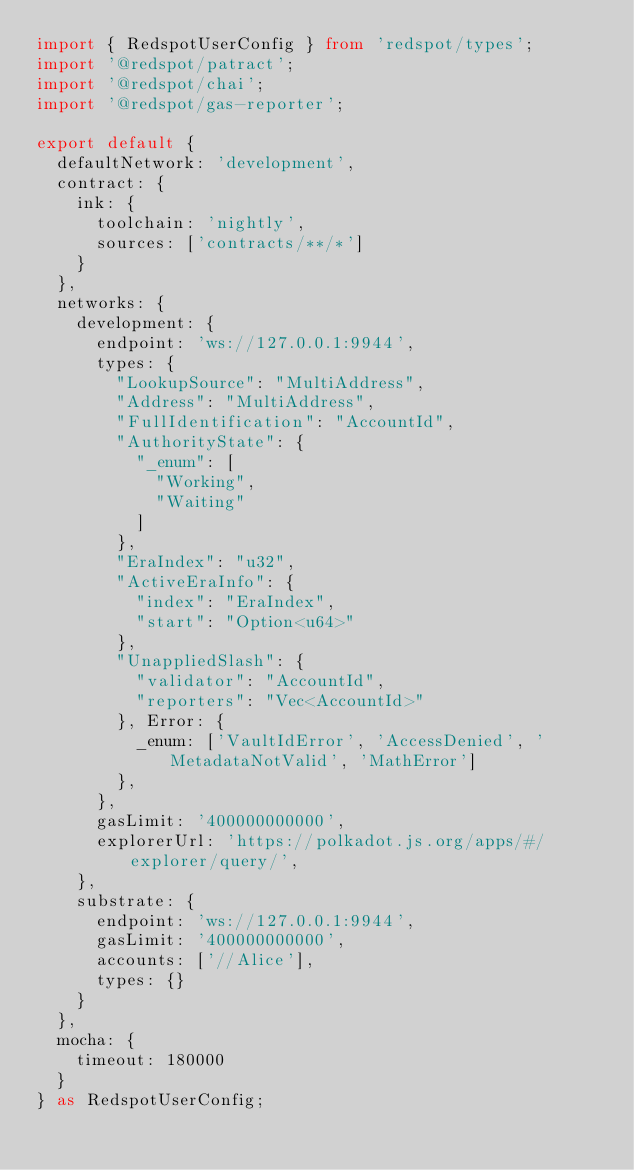<code> <loc_0><loc_0><loc_500><loc_500><_TypeScript_>import { RedspotUserConfig } from 'redspot/types';
import '@redspot/patract';
import '@redspot/chai';
import '@redspot/gas-reporter';

export default {
  defaultNetwork: 'development',
  contract: {
    ink: {
      toolchain: 'nightly',
      sources: ['contracts/**/*']
    }
  },
  networks: {
    development: {
      endpoint: 'ws://127.0.0.1:9944',
      types: {
        "LookupSource": "MultiAddress",
        "Address": "MultiAddress",
        "FullIdentification": "AccountId",
        "AuthorityState": {
          "_enum": [
            "Working",
            "Waiting"
          ]
        },
        "EraIndex": "u32",
        "ActiveEraInfo": {
          "index": "EraIndex",
          "start": "Option<u64>"
        },
        "UnappliedSlash": {
          "validator": "AccountId",
          "reporters": "Vec<AccountId>"
        }, Error: {
          _enum: ['VaultIdError', 'AccessDenied', 'MetadataNotValid', 'MathError']
        }, 
      },
      gasLimit: '400000000000',
      explorerUrl: 'https://polkadot.js.org/apps/#/explorer/query/',
    },
    substrate: {
      endpoint: 'ws://127.0.0.1:9944',
      gasLimit: '400000000000',
      accounts: ['//Alice'],
      types: {}
    }
  },
  mocha: {
    timeout: 180000
  }
} as RedspotUserConfig;
</code> 